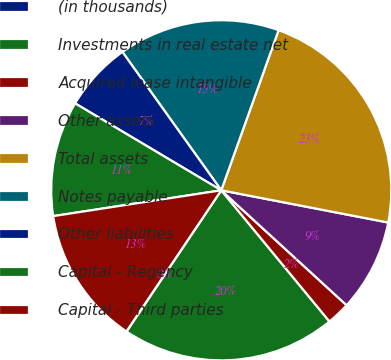Convert chart to OTSL. <chart><loc_0><loc_0><loc_500><loc_500><pie_chart><fcel>(in thousands)<fcel>Investments in real estate net<fcel>Acquired lease intangible<fcel>Other assets<fcel>Total assets<fcel>Notes payable<fcel>Other liabilities<fcel>Capital - Regency<fcel>Capital - Third parties<nl><fcel>0.02%<fcel>20.38%<fcel>2.21%<fcel>8.78%<fcel>22.57%<fcel>15.35%<fcel>6.59%<fcel>10.97%<fcel>13.16%<nl></chart> 